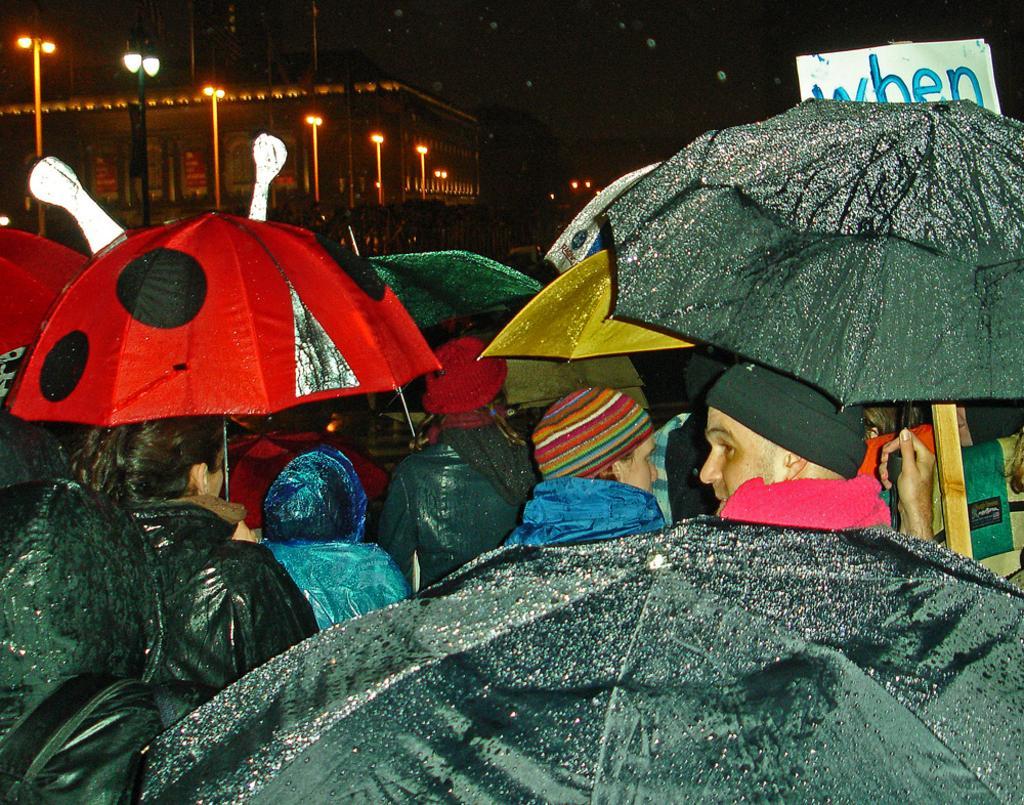Please provide a concise description of this image. In the foreground of the picture we can see a lot of people, they are wearing jacket and caps. Many of the people are holding umbrellas. In the background we can see street lights, building and mostly it is dark. 